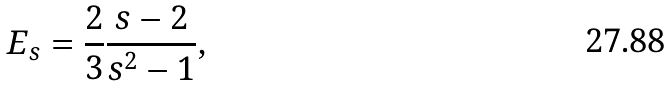<formula> <loc_0><loc_0><loc_500><loc_500>E _ { s } = \frac { 2 } { 3 } \frac { s - 2 } { s ^ { 2 } - 1 } ,</formula> 